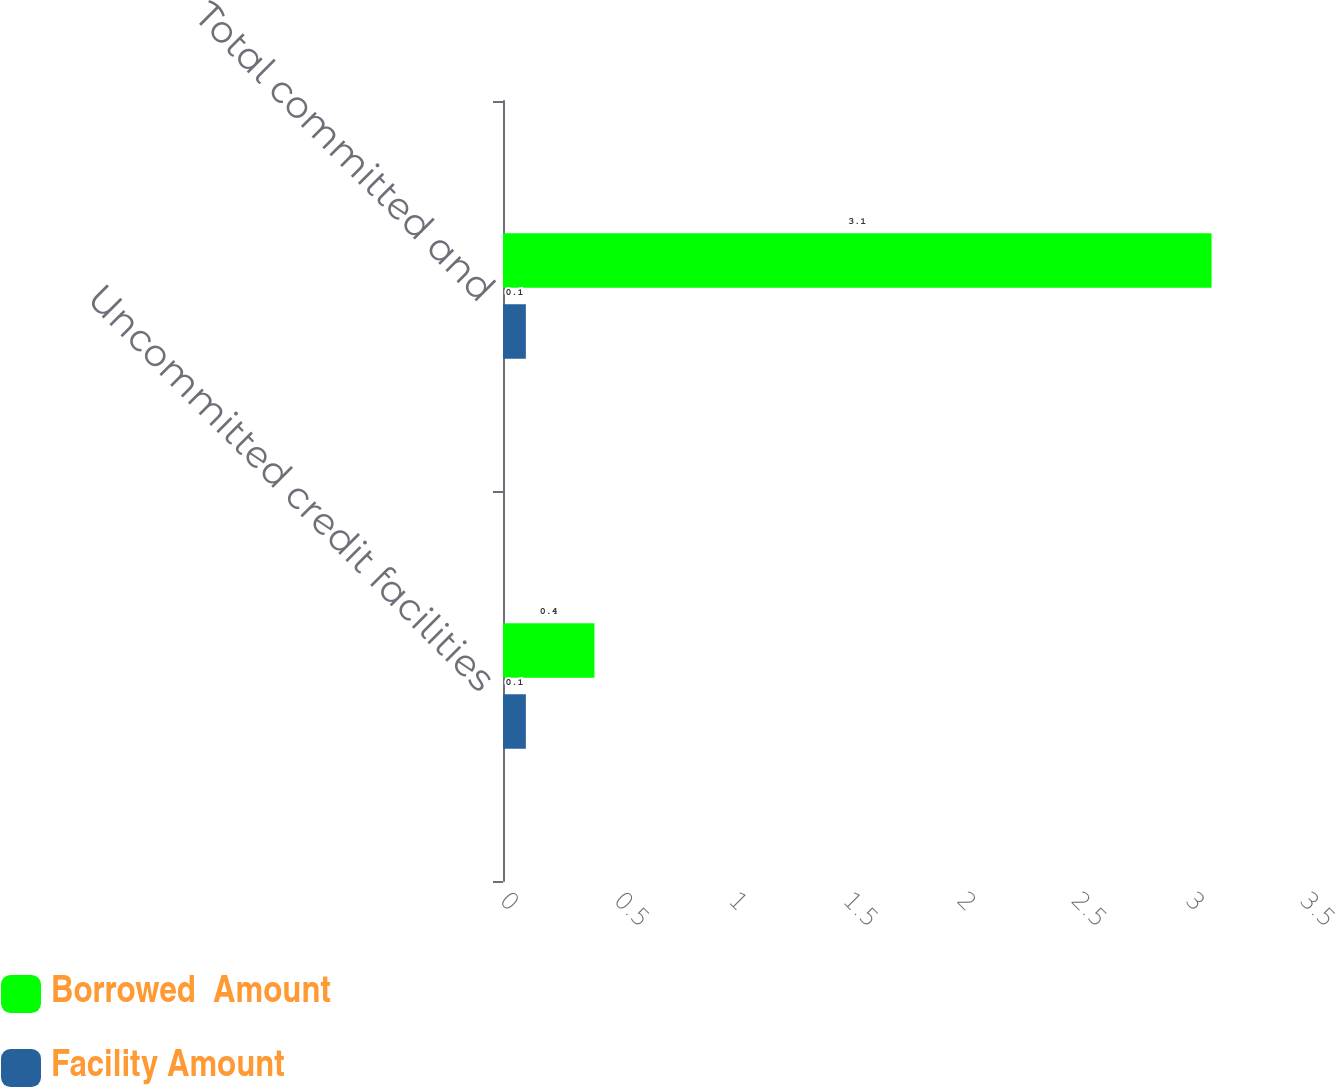Convert chart. <chart><loc_0><loc_0><loc_500><loc_500><stacked_bar_chart><ecel><fcel>Uncommitted credit facilities<fcel>Total committed and<nl><fcel>Borrowed  Amount<fcel>0.4<fcel>3.1<nl><fcel>Facility Amount<fcel>0.1<fcel>0.1<nl></chart> 